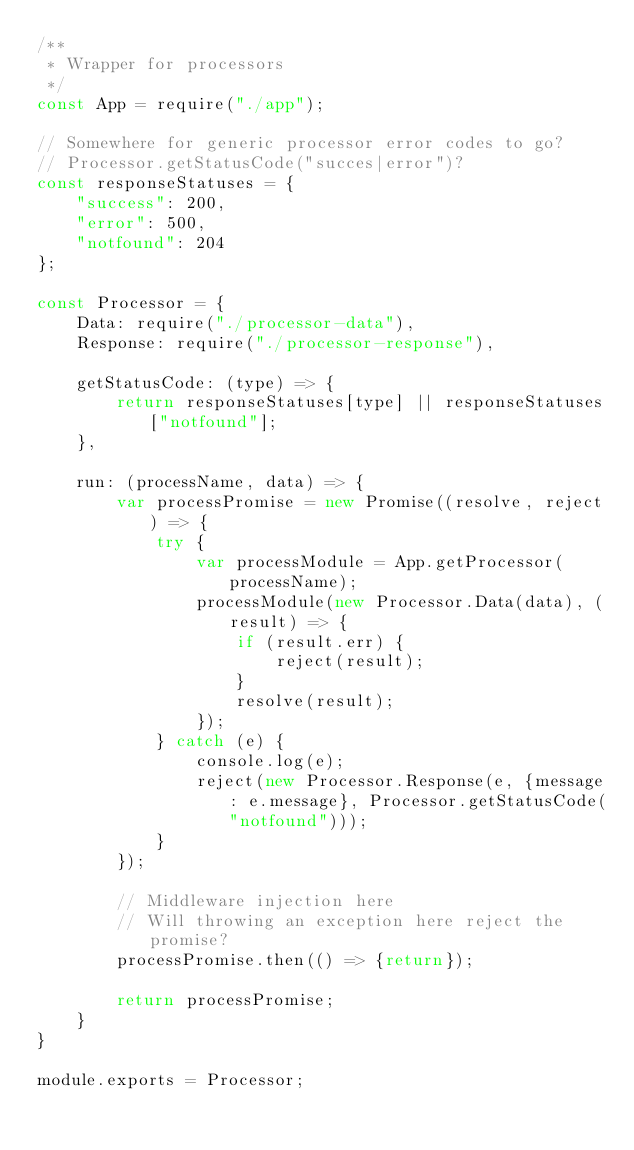<code> <loc_0><loc_0><loc_500><loc_500><_JavaScript_>/**
 * Wrapper for processors
 */
const App = require("./app");

// Somewhere for generic processor error codes to go?
// Processor.getStatusCode("succes|error")?
const responseStatuses = {
    "success": 200,
    "error": 500,
    "notfound": 204
};

const Processor = {
    Data: require("./processor-data"),
    Response: require("./processor-response"),

    getStatusCode: (type) => {
        return responseStatuses[type] || responseStatuses["notfound"];
    },

    run: (processName, data) => {
        var processPromise = new Promise((resolve, reject) => {
            try {
                var processModule = App.getProcessor(processName);
                processModule(new Processor.Data(data), (result) => {
                    if (result.err) {
                        reject(result);
                    }
                    resolve(result); 
                });
            } catch (e) {
                console.log(e);
                reject(new Processor.Response(e, {message: e.message}, Processor.getStatusCode("notfound")));
            }
        });

        // Middleware injection here
        // Will throwing an exception here reject the promise?
        processPromise.then(() => {return});

        return processPromise;
    }
}

module.exports = Processor;</code> 